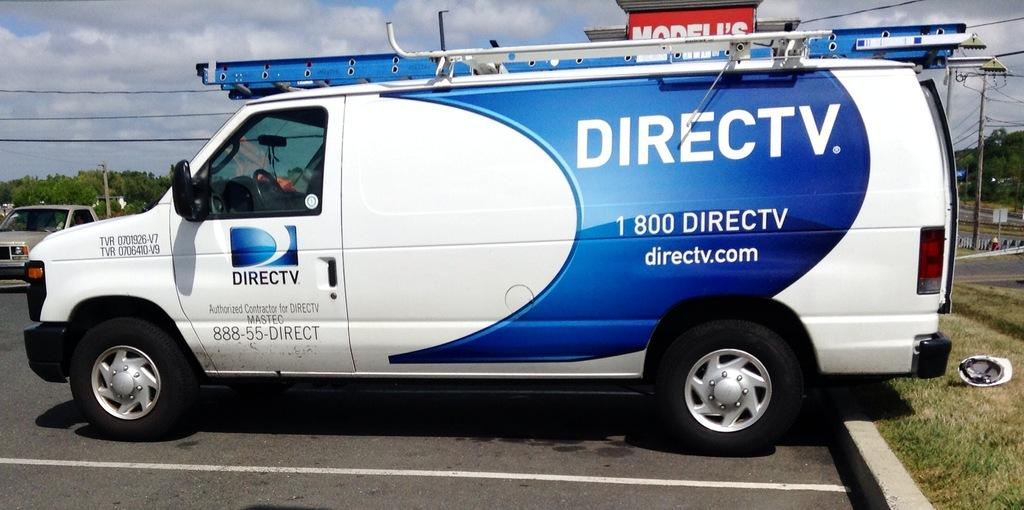<image>
Create a compact narrative representing the image presented. DirecTV van, white with blue accent blue side view. 